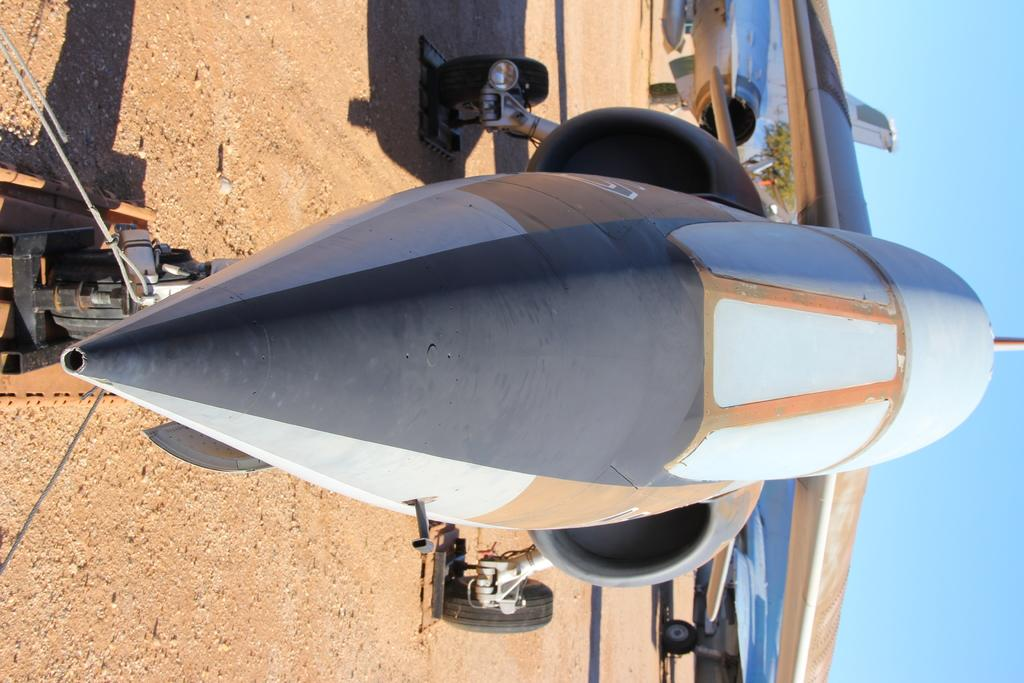What is the main subject of the image? The main subject of the image is airplanes on the ground. What can be seen in the background of the image? There is a tree and the sky visible in the background of the image. What advertisement can be seen on the side of the airplanes in the image? There is no advertisement visible on the airplanes in the image. In which direction are the airplanes facing in the image? The image does not provide information about the direction the airplanes are facing. 